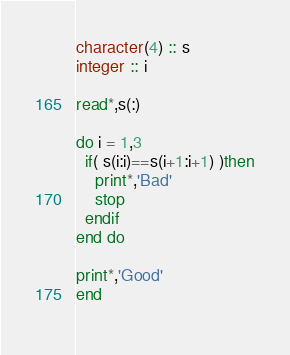<code> <loc_0><loc_0><loc_500><loc_500><_FORTRAN_>character(4) :: s
integer :: i

read*,s(:)

do i = 1,3
  if( s(i:i)==s(i+1:i+1) )then
    print*,'Bad'
    stop
  endif
end do

print*,'Good'
end
  
</code> 